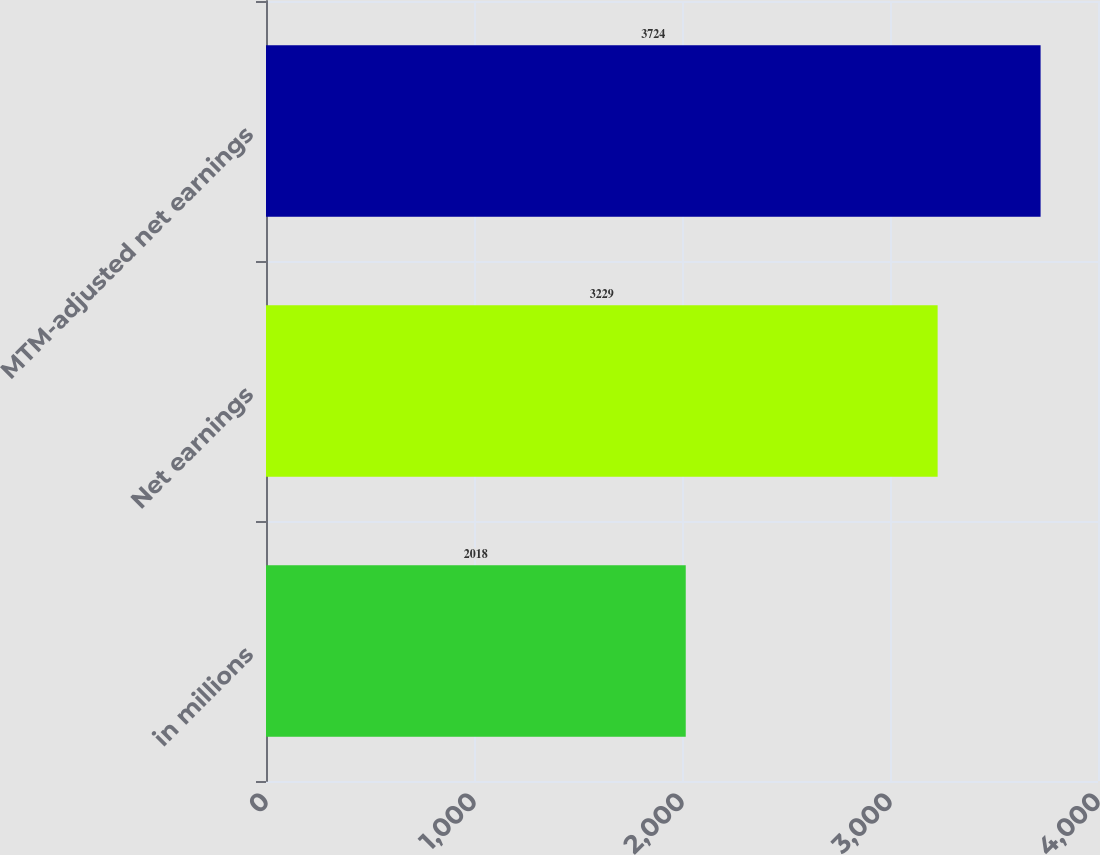Convert chart to OTSL. <chart><loc_0><loc_0><loc_500><loc_500><bar_chart><fcel>in millions<fcel>Net earnings<fcel>MTM-adjusted net earnings<nl><fcel>2018<fcel>3229<fcel>3724<nl></chart> 